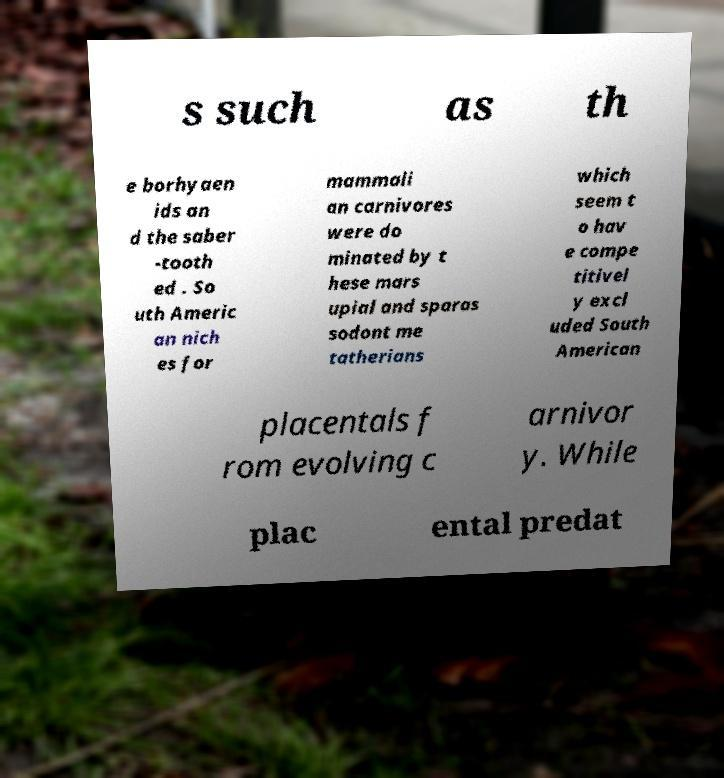Please identify and transcribe the text found in this image. s such as th e borhyaen ids an d the saber -tooth ed . So uth Americ an nich es for mammali an carnivores were do minated by t hese mars upial and sparas sodont me tatherians which seem t o hav e compe titivel y excl uded South American placentals f rom evolving c arnivor y. While plac ental predat 